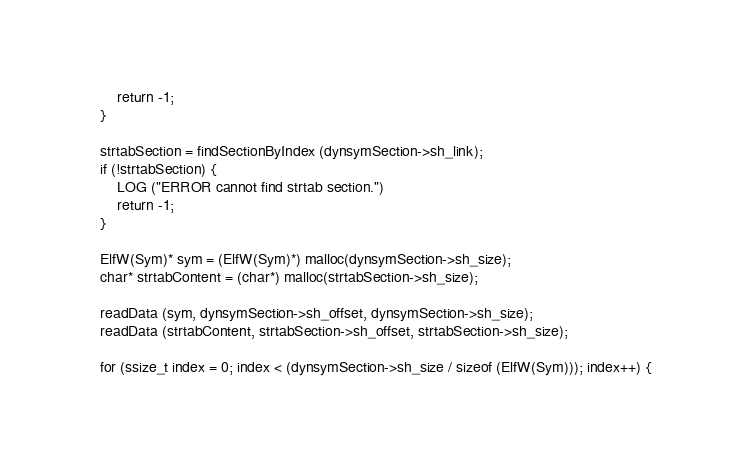Convert code to text. <code><loc_0><loc_0><loc_500><loc_500><_C++_>        return -1;
    }

    strtabSection = findSectionByIndex (dynsymSection->sh_link);
    if (!strtabSection) {
        LOG ("ERROR cannot find strtab section.")
        return -1;
    }

    ElfW(Sym)* sym = (ElfW(Sym)*) malloc(dynsymSection->sh_size);
    char* strtabContent = (char*) malloc(strtabSection->sh_size);

    readData (sym, dynsymSection->sh_offset, dynsymSection->sh_size);
    readData (strtabContent, strtabSection->sh_offset, strtabSection->sh_size);

    for (ssize_t index = 0; index < (dynsymSection->sh_size / sizeof (ElfW(Sym))); index++) {</code> 